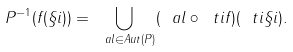Convert formula to latex. <formula><loc_0><loc_0><loc_500><loc_500>P ^ { - 1 } ( f ( \S i ) ) = \bigcup _ { \ a l \in A u t ( P ) } ( \ a l \circ \ t i f ) ( \ t i \S i ) .</formula> 